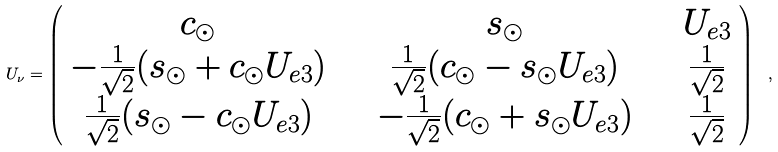<formula> <loc_0><loc_0><loc_500><loc_500>U _ { \nu } = \left ( \begin{array} { c c c } c _ { \odot } & \quad s _ { \odot } & \quad U _ { e 3 } \\ - \frac { 1 } { \sqrt { 2 } } ( s _ { \odot } + c _ { \odot } U _ { e 3 } ) & \quad \frac { 1 } { \sqrt { 2 } } ( c _ { \odot } - s _ { \odot } U _ { e 3 } ) & \quad \frac { 1 } { \sqrt { 2 } } \\ \frac { 1 } { \sqrt { 2 } } ( s _ { \odot } - c _ { \odot } U _ { e 3 } ) & \quad - \frac { 1 } { \sqrt { 2 } } ( c _ { \odot } + s _ { \odot } U _ { e 3 } ) & \quad \frac { 1 } { \sqrt { 2 } } \end{array} \right ) \ ,</formula> 